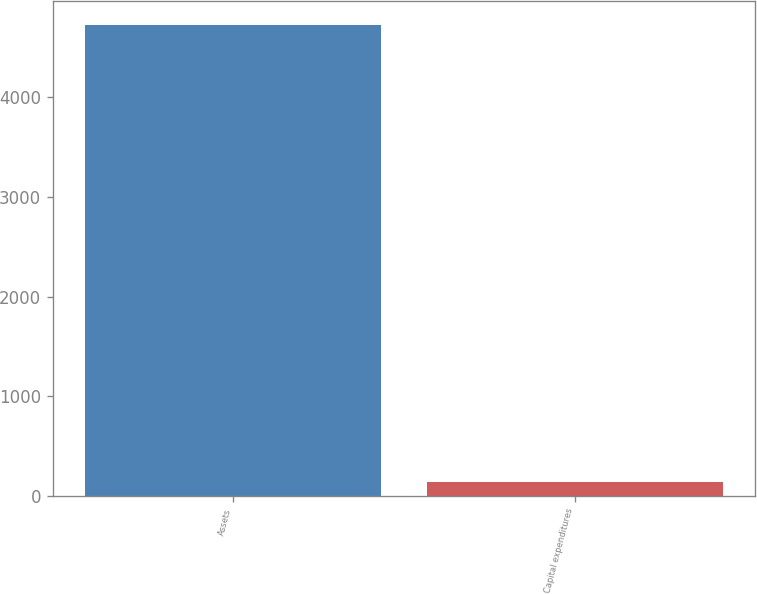<chart> <loc_0><loc_0><loc_500><loc_500><bar_chart><fcel>Assets<fcel>Capital expenditures<nl><fcel>4729<fcel>139<nl></chart> 